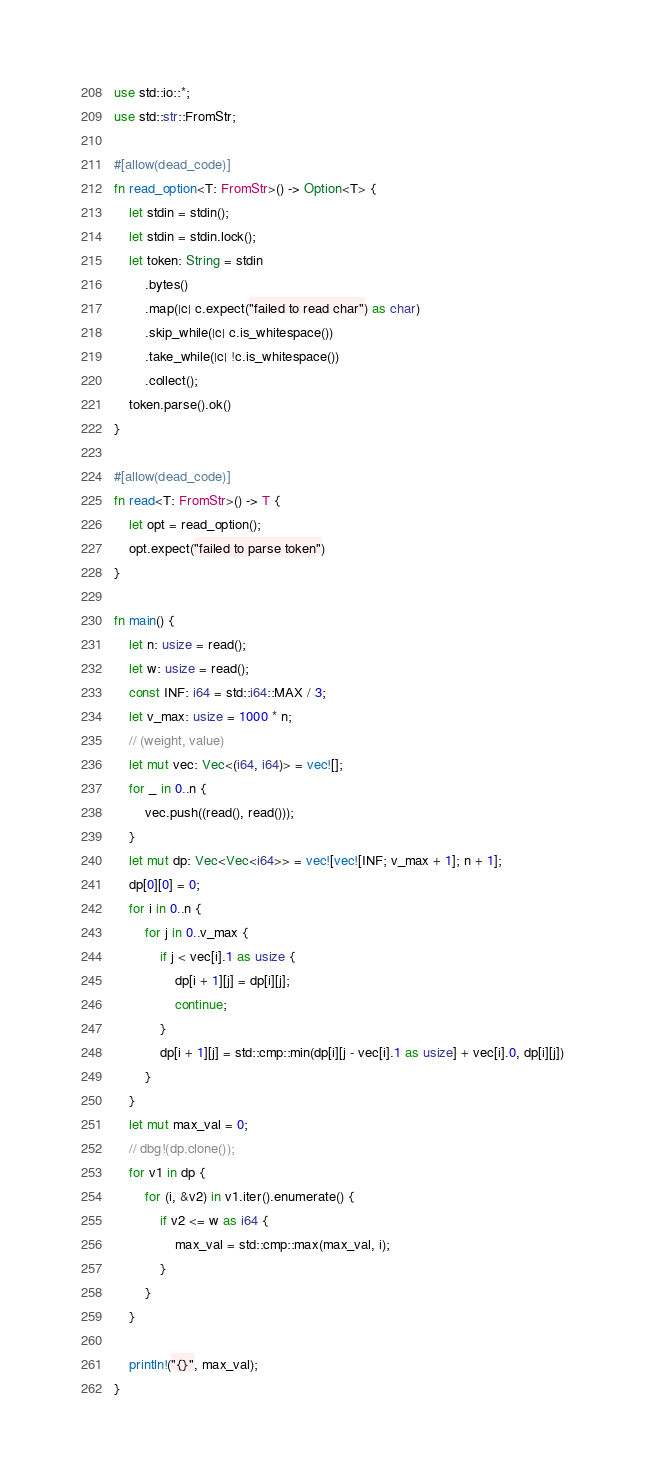Convert code to text. <code><loc_0><loc_0><loc_500><loc_500><_Rust_>use std::io::*;
use std::str::FromStr;

#[allow(dead_code)]
fn read_option<T: FromStr>() -> Option<T> {
    let stdin = stdin();
    let stdin = stdin.lock();
    let token: String = stdin
        .bytes()
        .map(|c| c.expect("failed to read char") as char)
        .skip_while(|c| c.is_whitespace())
        .take_while(|c| !c.is_whitespace())
        .collect();
    token.parse().ok()
}

#[allow(dead_code)]
fn read<T: FromStr>() -> T {
    let opt = read_option();
    opt.expect("failed to parse token")
}

fn main() {
    let n: usize = read();
    let w: usize = read();
    const INF: i64 = std::i64::MAX / 3;
    let v_max: usize = 1000 * n;
    // (weight, value)
    let mut vec: Vec<(i64, i64)> = vec![];
    for _ in 0..n {
        vec.push((read(), read()));
    }
    let mut dp: Vec<Vec<i64>> = vec![vec![INF; v_max + 1]; n + 1];
    dp[0][0] = 0;
    for i in 0..n {
        for j in 0..v_max {
            if j < vec[i].1 as usize {
                dp[i + 1][j] = dp[i][j];
                continue;
            }
            dp[i + 1][j] = std::cmp::min(dp[i][j - vec[i].1 as usize] + vec[i].0, dp[i][j])
        }
    }
    let mut max_val = 0;
    // dbg!(dp.clone());
    for v1 in dp {
        for (i, &v2) in v1.iter().enumerate() {
            if v2 <= w as i64 {
                max_val = std::cmp::max(max_val, i);
            }
        }
    }

    println!("{}", max_val);
}
</code> 